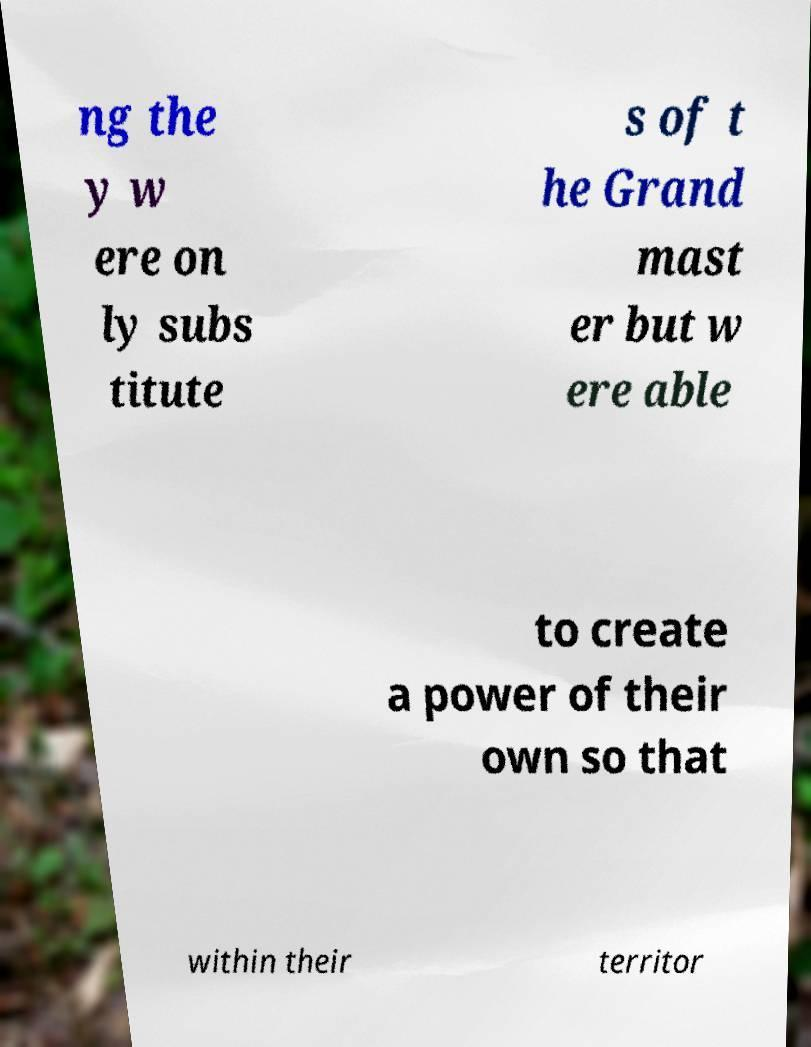There's text embedded in this image that I need extracted. Can you transcribe it verbatim? ng the y w ere on ly subs titute s of t he Grand mast er but w ere able to create a power of their own so that within their territor 